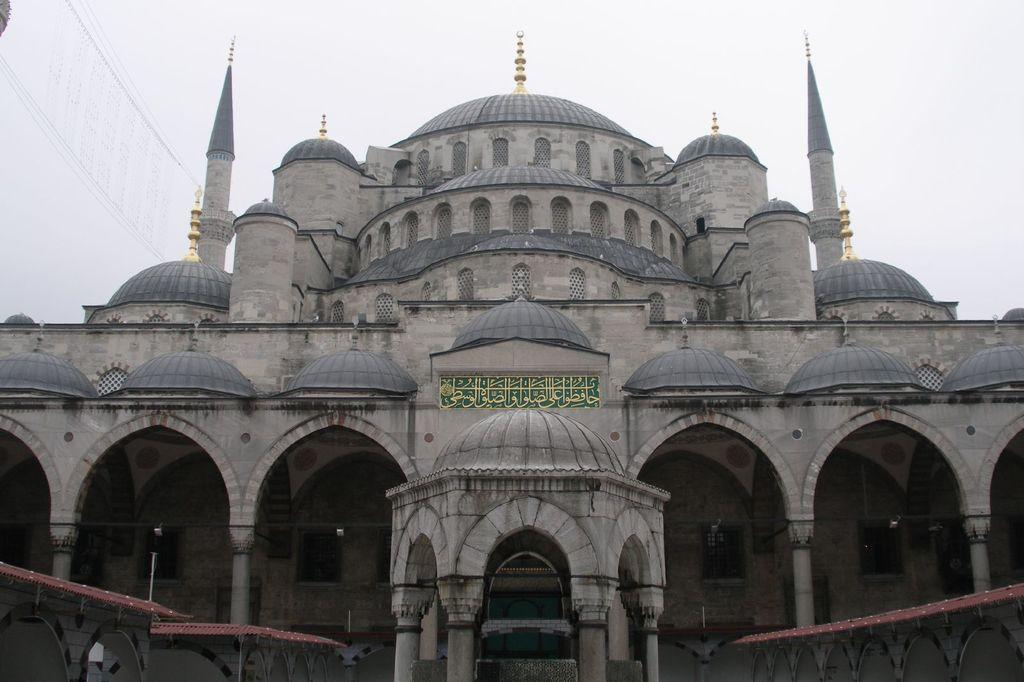What type of building is featured in the image? There is a historical mosque in the picture. What color is the mosque? The mosque is gray in color. What symbol can be seen on top of the mosque? There is a moon symbol on top of the mosque. What can be seen in the background of the image? The sky is visible in the background of the image. Where can the silk be found in the image? There is no silk present in the image. How many apples are hanging from the moon symbol on the mosque? There are no apples depicted in the image, and the moon symbol is not associated with apples. 